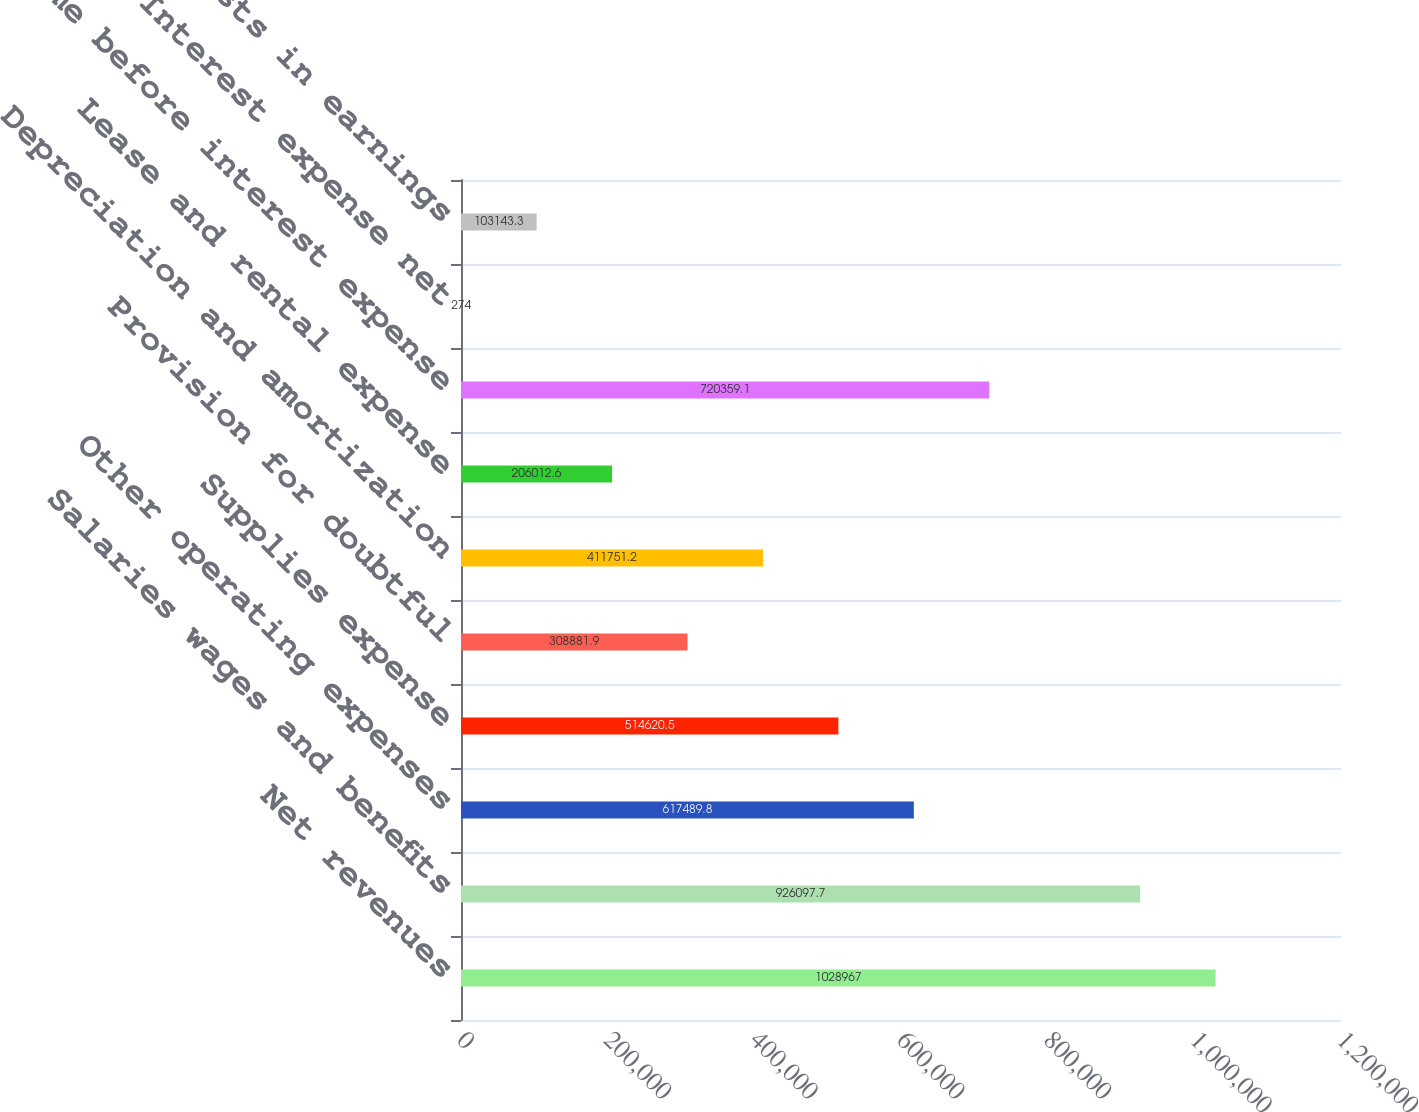Convert chart to OTSL. <chart><loc_0><loc_0><loc_500><loc_500><bar_chart><fcel>Net revenues<fcel>Salaries wages and benefits<fcel>Other operating expenses<fcel>Supplies expense<fcel>Provision for doubtful<fcel>Depreciation and amortization<fcel>Lease and rental expense<fcel>Income before interest expense<fcel>Interest expense net<fcel>Minority interests in earnings<nl><fcel>1.02897e+06<fcel>926098<fcel>617490<fcel>514620<fcel>308882<fcel>411751<fcel>206013<fcel>720359<fcel>274<fcel>103143<nl></chart> 